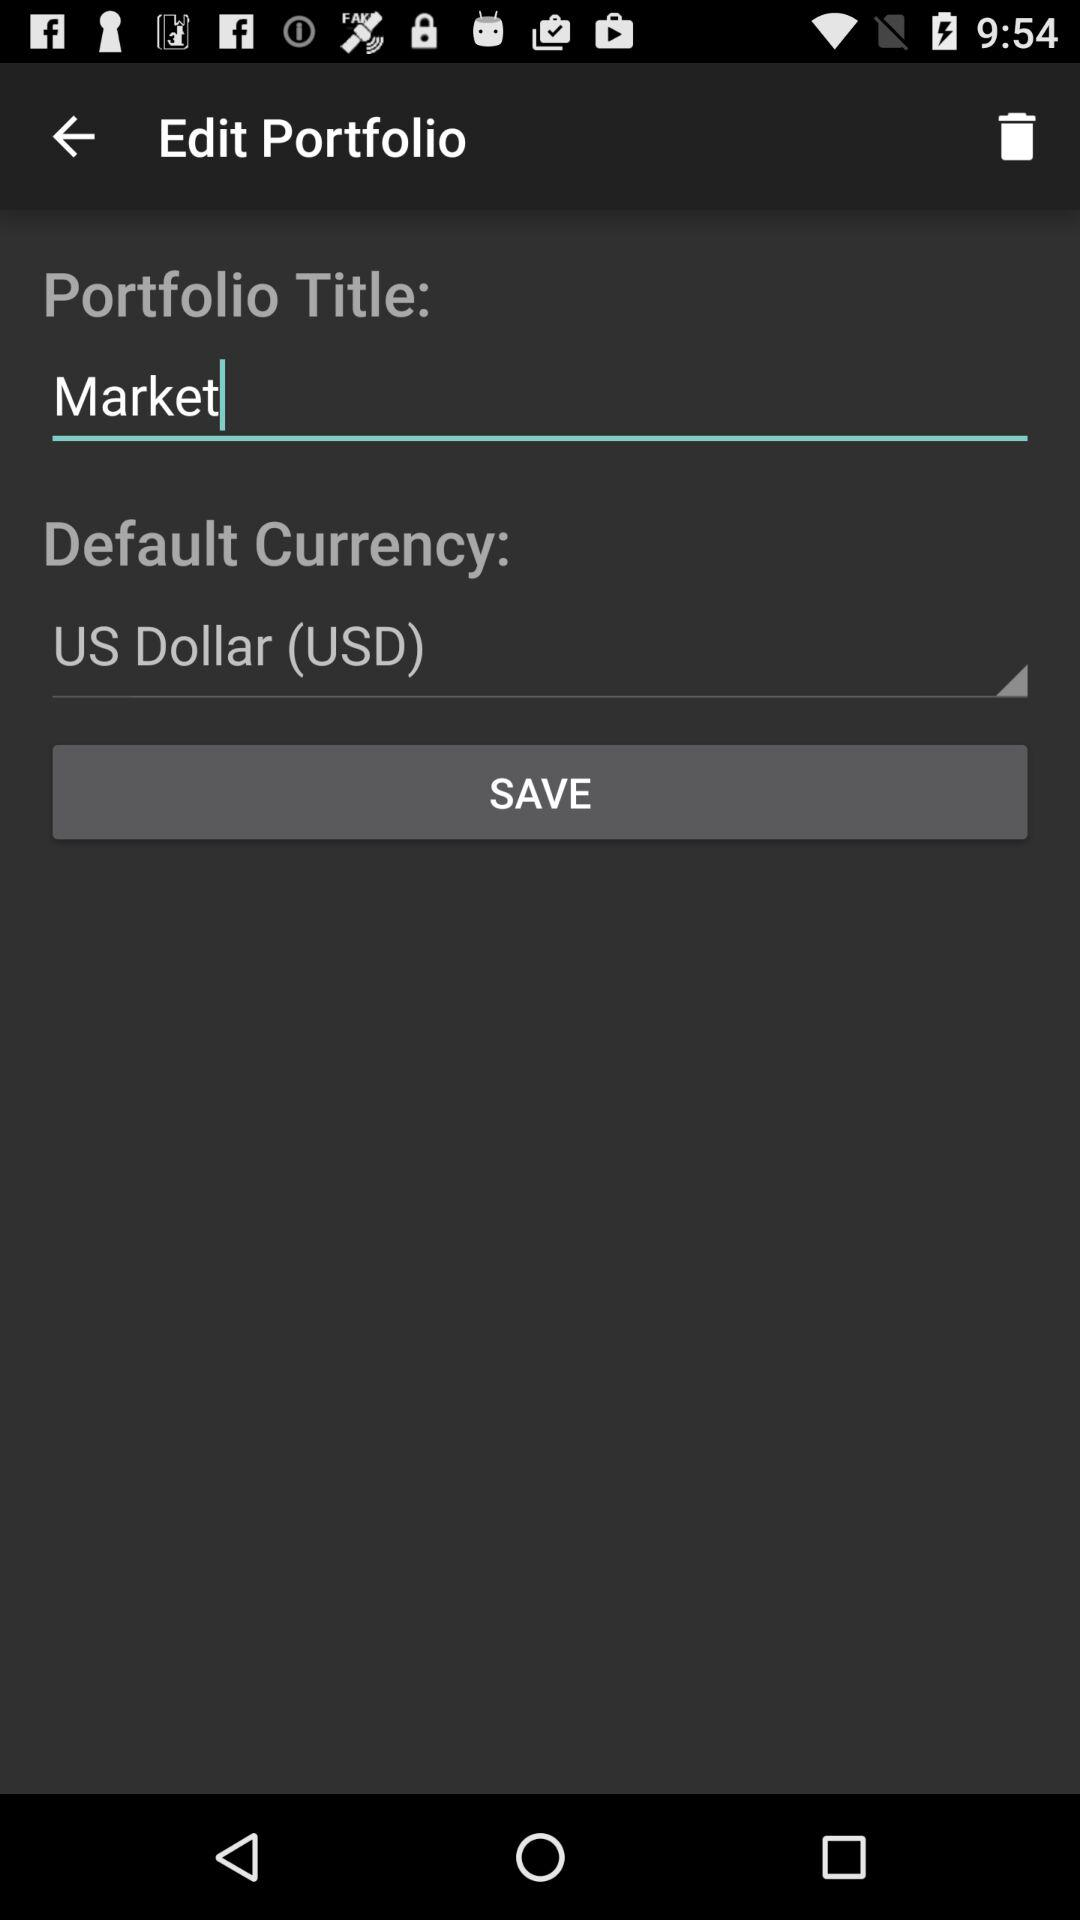What's the selected default currency? The selected currency is the US dollar (USD). 